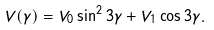Convert formula to latex. <formula><loc_0><loc_0><loc_500><loc_500>V ( \gamma ) = V _ { 0 } \sin ^ { 2 } 3 \gamma + V _ { 1 } \cos 3 \gamma .</formula> 